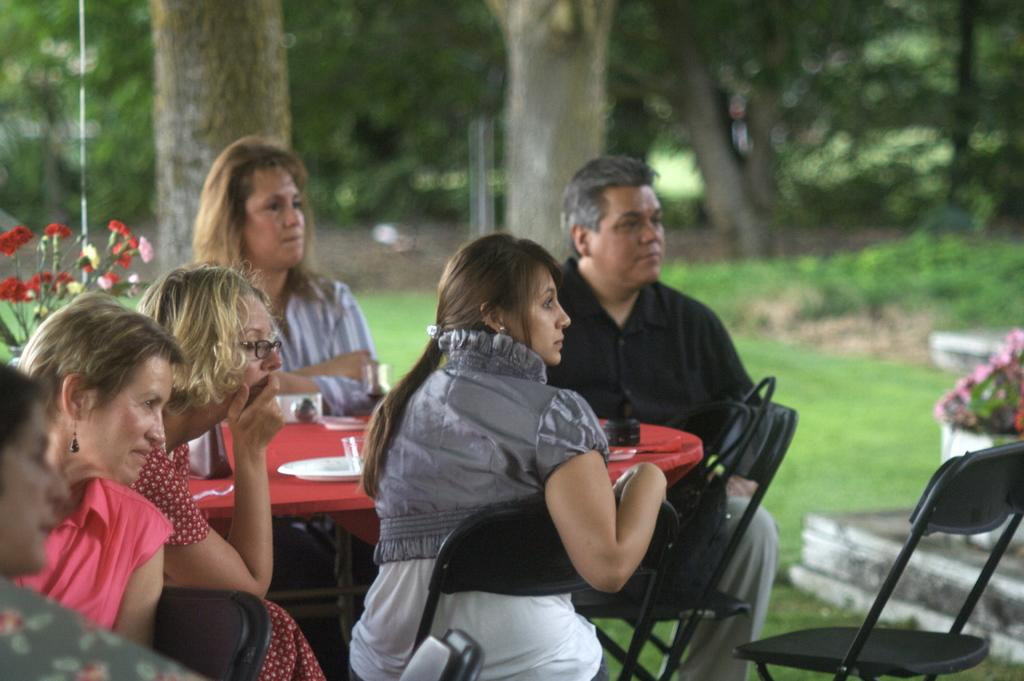How many people are in the image? There are people in the image, including one man and several women. What type of furniture is present in the image? There are chairs and a table in the image. What type of vegetation can be seen in the image? There are plants and trees in the image. What theory is the man discussing with his brothers in the image? There is no mention of a theory or brothers in the image; it only shows people, chairs, a table, plants, and trees. 